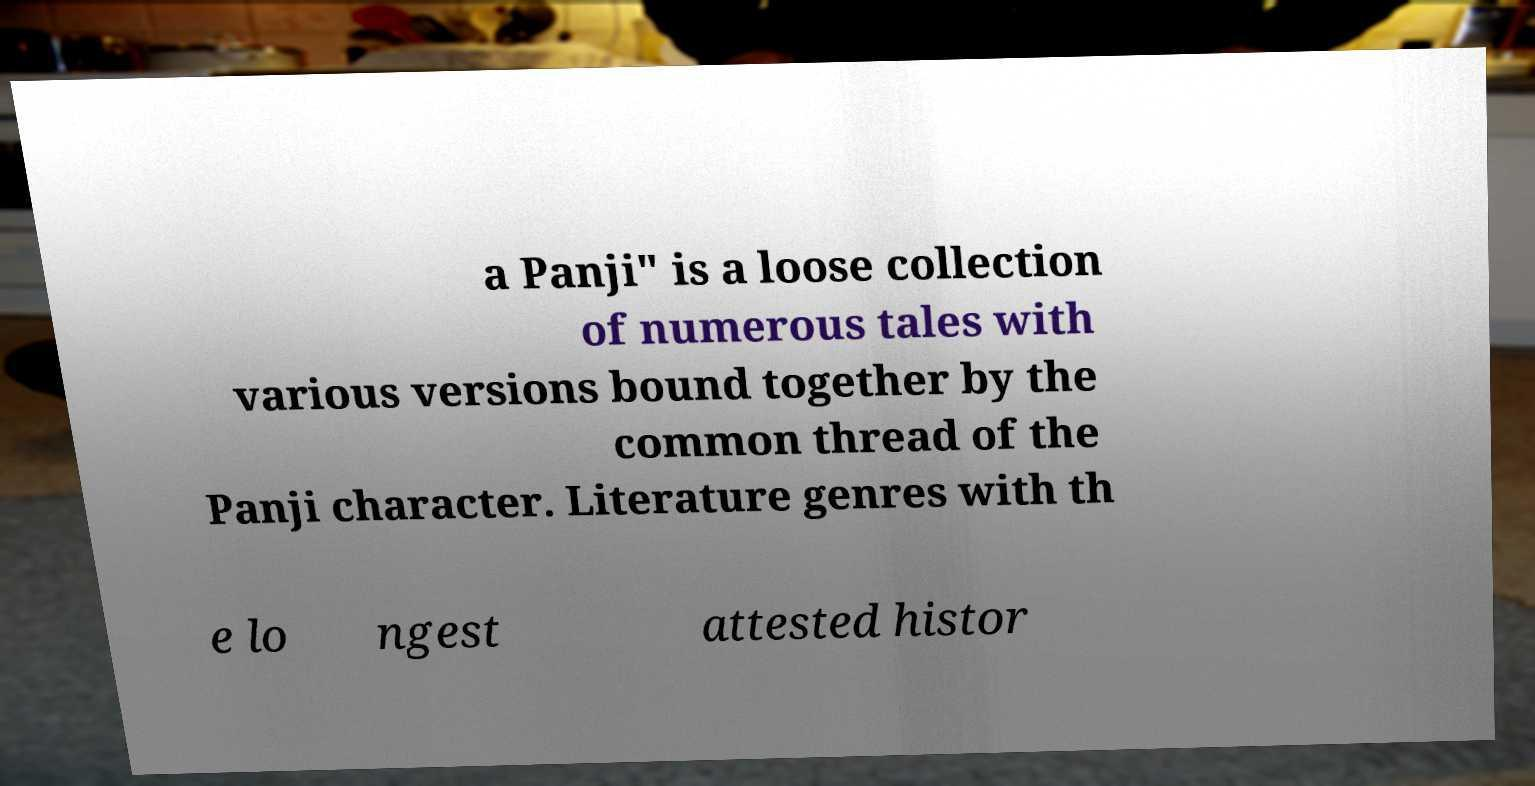Please read and relay the text visible in this image. What does it say? a Panji" is a loose collection of numerous tales with various versions bound together by the common thread of the Panji character. Literature genres with th e lo ngest attested histor 